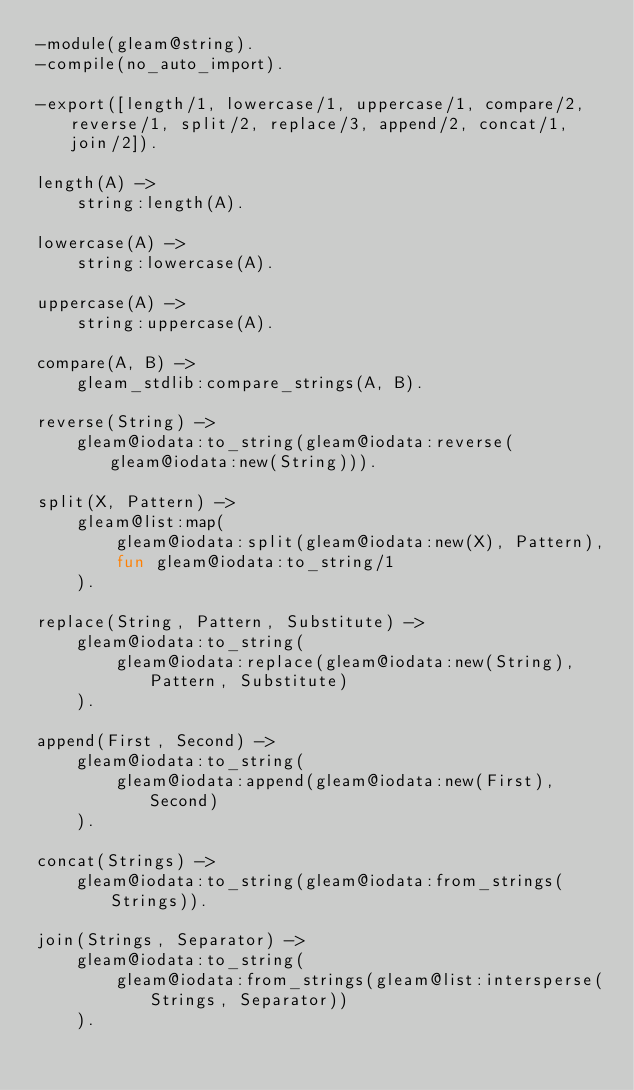<code> <loc_0><loc_0><loc_500><loc_500><_Erlang_>-module(gleam@string).
-compile(no_auto_import).

-export([length/1, lowercase/1, uppercase/1, compare/2, reverse/1, split/2, replace/3, append/2, concat/1, join/2]).

length(A) ->
    string:length(A).

lowercase(A) ->
    string:lowercase(A).

uppercase(A) ->
    string:uppercase(A).

compare(A, B) ->
    gleam_stdlib:compare_strings(A, B).

reverse(String) ->
    gleam@iodata:to_string(gleam@iodata:reverse(gleam@iodata:new(String))).

split(X, Pattern) ->
    gleam@list:map(
        gleam@iodata:split(gleam@iodata:new(X), Pattern),
        fun gleam@iodata:to_string/1
    ).

replace(String, Pattern, Substitute) ->
    gleam@iodata:to_string(
        gleam@iodata:replace(gleam@iodata:new(String), Pattern, Substitute)
    ).

append(First, Second) ->
    gleam@iodata:to_string(
        gleam@iodata:append(gleam@iodata:new(First), Second)
    ).

concat(Strings) ->
    gleam@iodata:to_string(gleam@iodata:from_strings(Strings)).

join(Strings, Separator) ->
    gleam@iodata:to_string(
        gleam@iodata:from_strings(gleam@list:intersperse(Strings, Separator))
    ).
</code> 